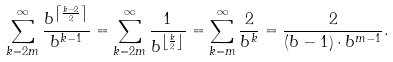<formula> <loc_0><loc_0><loc_500><loc_500>\sum _ { k = 2 m } ^ { \infty } \frac { b ^ { \left \lceil \frac { k - 2 } { 2 } \right \rceil } } { b ^ { k - 1 } } = \sum _ { k = 2 m } ^ { \infty } \frac { 1 } { b ^ { \left \lfloor \frac { k } { 2 } \right \rfloor } } = \sum _ { k = m } ^ { \infty } \frac { 2 } { b ^ { k } } = \frac { 2 } { ( b - 1 ) \cdot b ^ { m - 1 } } .</formula> 